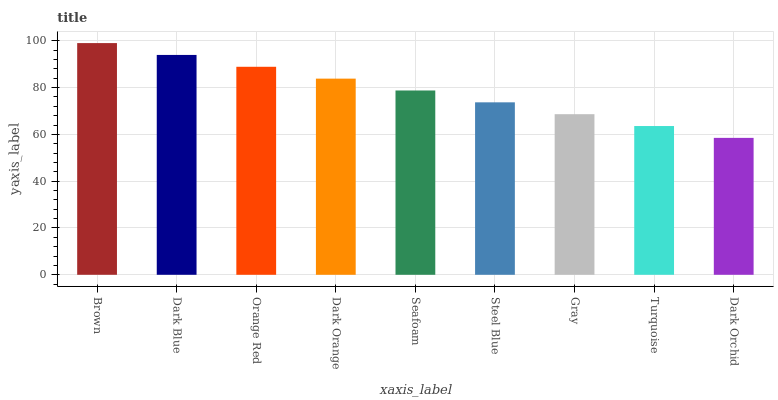Is Dark Orchid the minimum?
Answer yes or no. Yes. Is Brown the maximum?
Answer yes or no. Yes. Is Dark Blue the minimum?
Answer yes or no. No. Is Dark Blue the maximum?
Answer yes or no. No. Is Brown greater than Dark Blue?
Answer yes or no. Yes. Is Dark Blue less than Brown?
Answer yes or no. Yes. Is Dark Blue greater than Brown?
Answer yes or no. No. Is Brown less than Dark Blue?
Answer yes or no. No. Is Seafoam the high median?
Answer yes or no. Yes. Is Seafoam the low median?
Answer yes or no. Yes. Is Gray the high median?
Answer yes or no. No. Is Dark Orchid the low median?
Answer yes or no. No. 